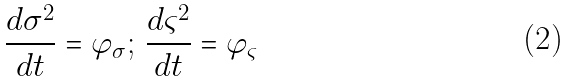Convert formula to latex. <formula><loc_0><loc_0><loc_500><loc_500>\frac { d \sigma ^ { 2 } } { d t } = \varphi _ { \sigma } ; \, \frac { d \varsigma ^ { 2 } } { d t } = \varphi _ { \varsigma }</formula> 